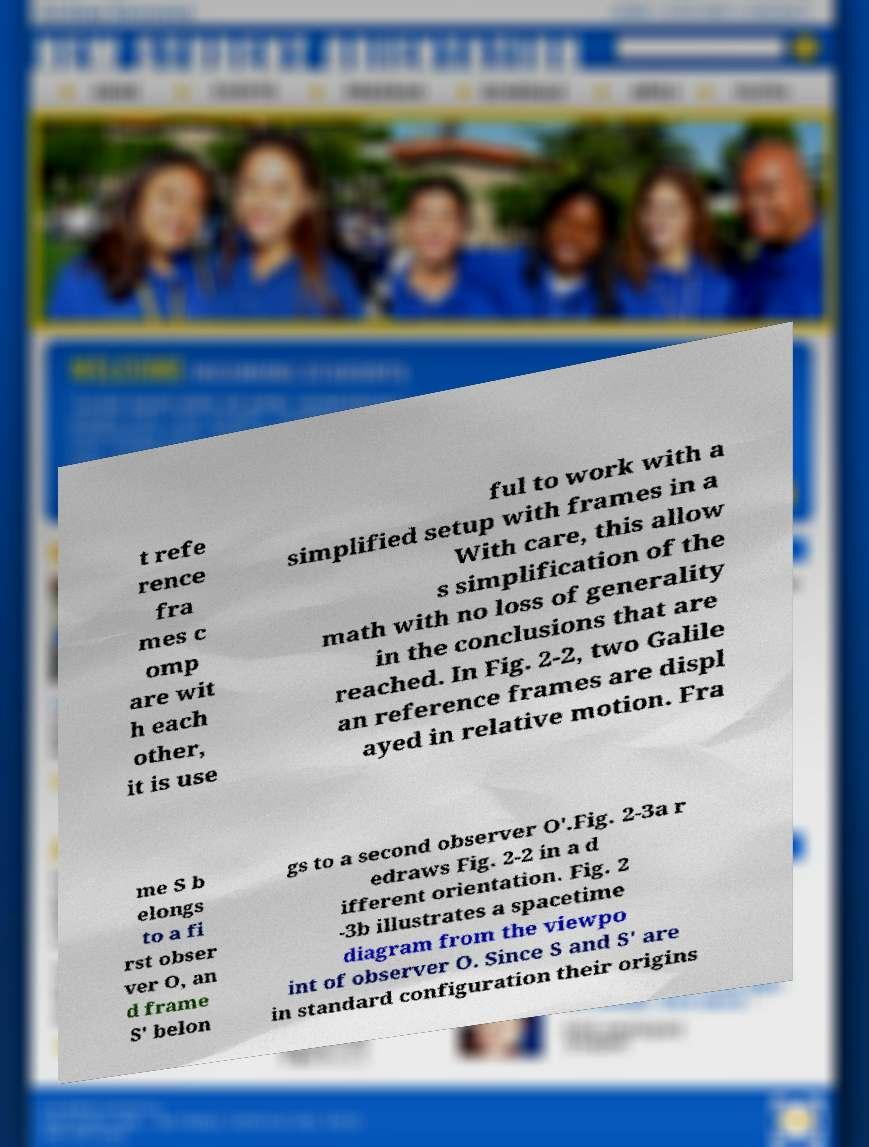Can you read and provide the text displayed in the image?This photo seems to have some interesting text. Can you extract and type it out for me? t refe rence fra mes c omp are wit h each other, it is use ful to work with a simplified setup with frames in a With care, this allow s simplification of the math with no loss of generality in the conclusions that are reached. In Fig. 2-2, two Galile an reference frames are displ ayed in relative motion. Fra me S b elongs to a fi rst obser ver O, an d frame S′ belon gs to a second observer O′.Fig. 2-3a r edraws Fig. 2-2 in a d ifferent orientation. Fig. 2 -3b illustrates a spacetime diagram from the viewpo int of observer O. Since S and S′ are in standard configuration their origins 